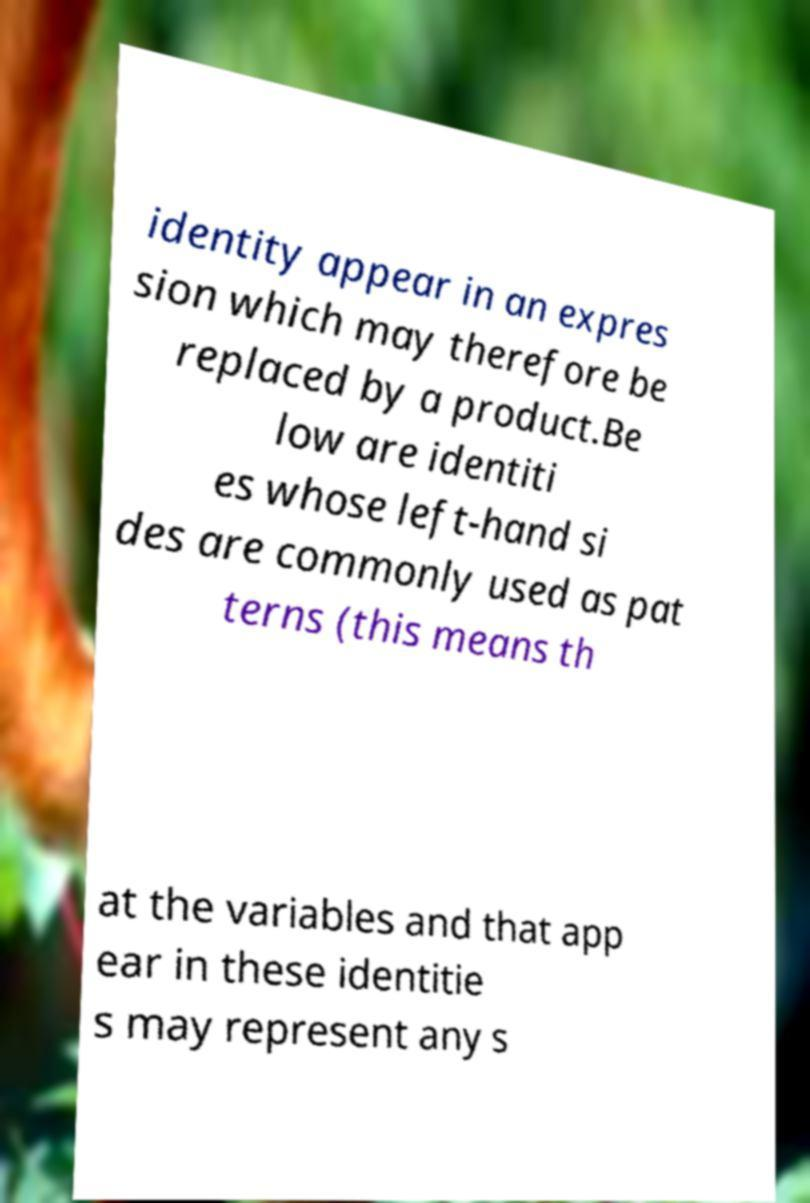Can you accurately transcribe the text from the provided image for me? identity appear in an expres sion which may therefore be replaced by a product.Be low are identiti es whose left-hand si des are commonly used as pat terns (this means th at the variables and that app ear in these identitie s may represent any s 